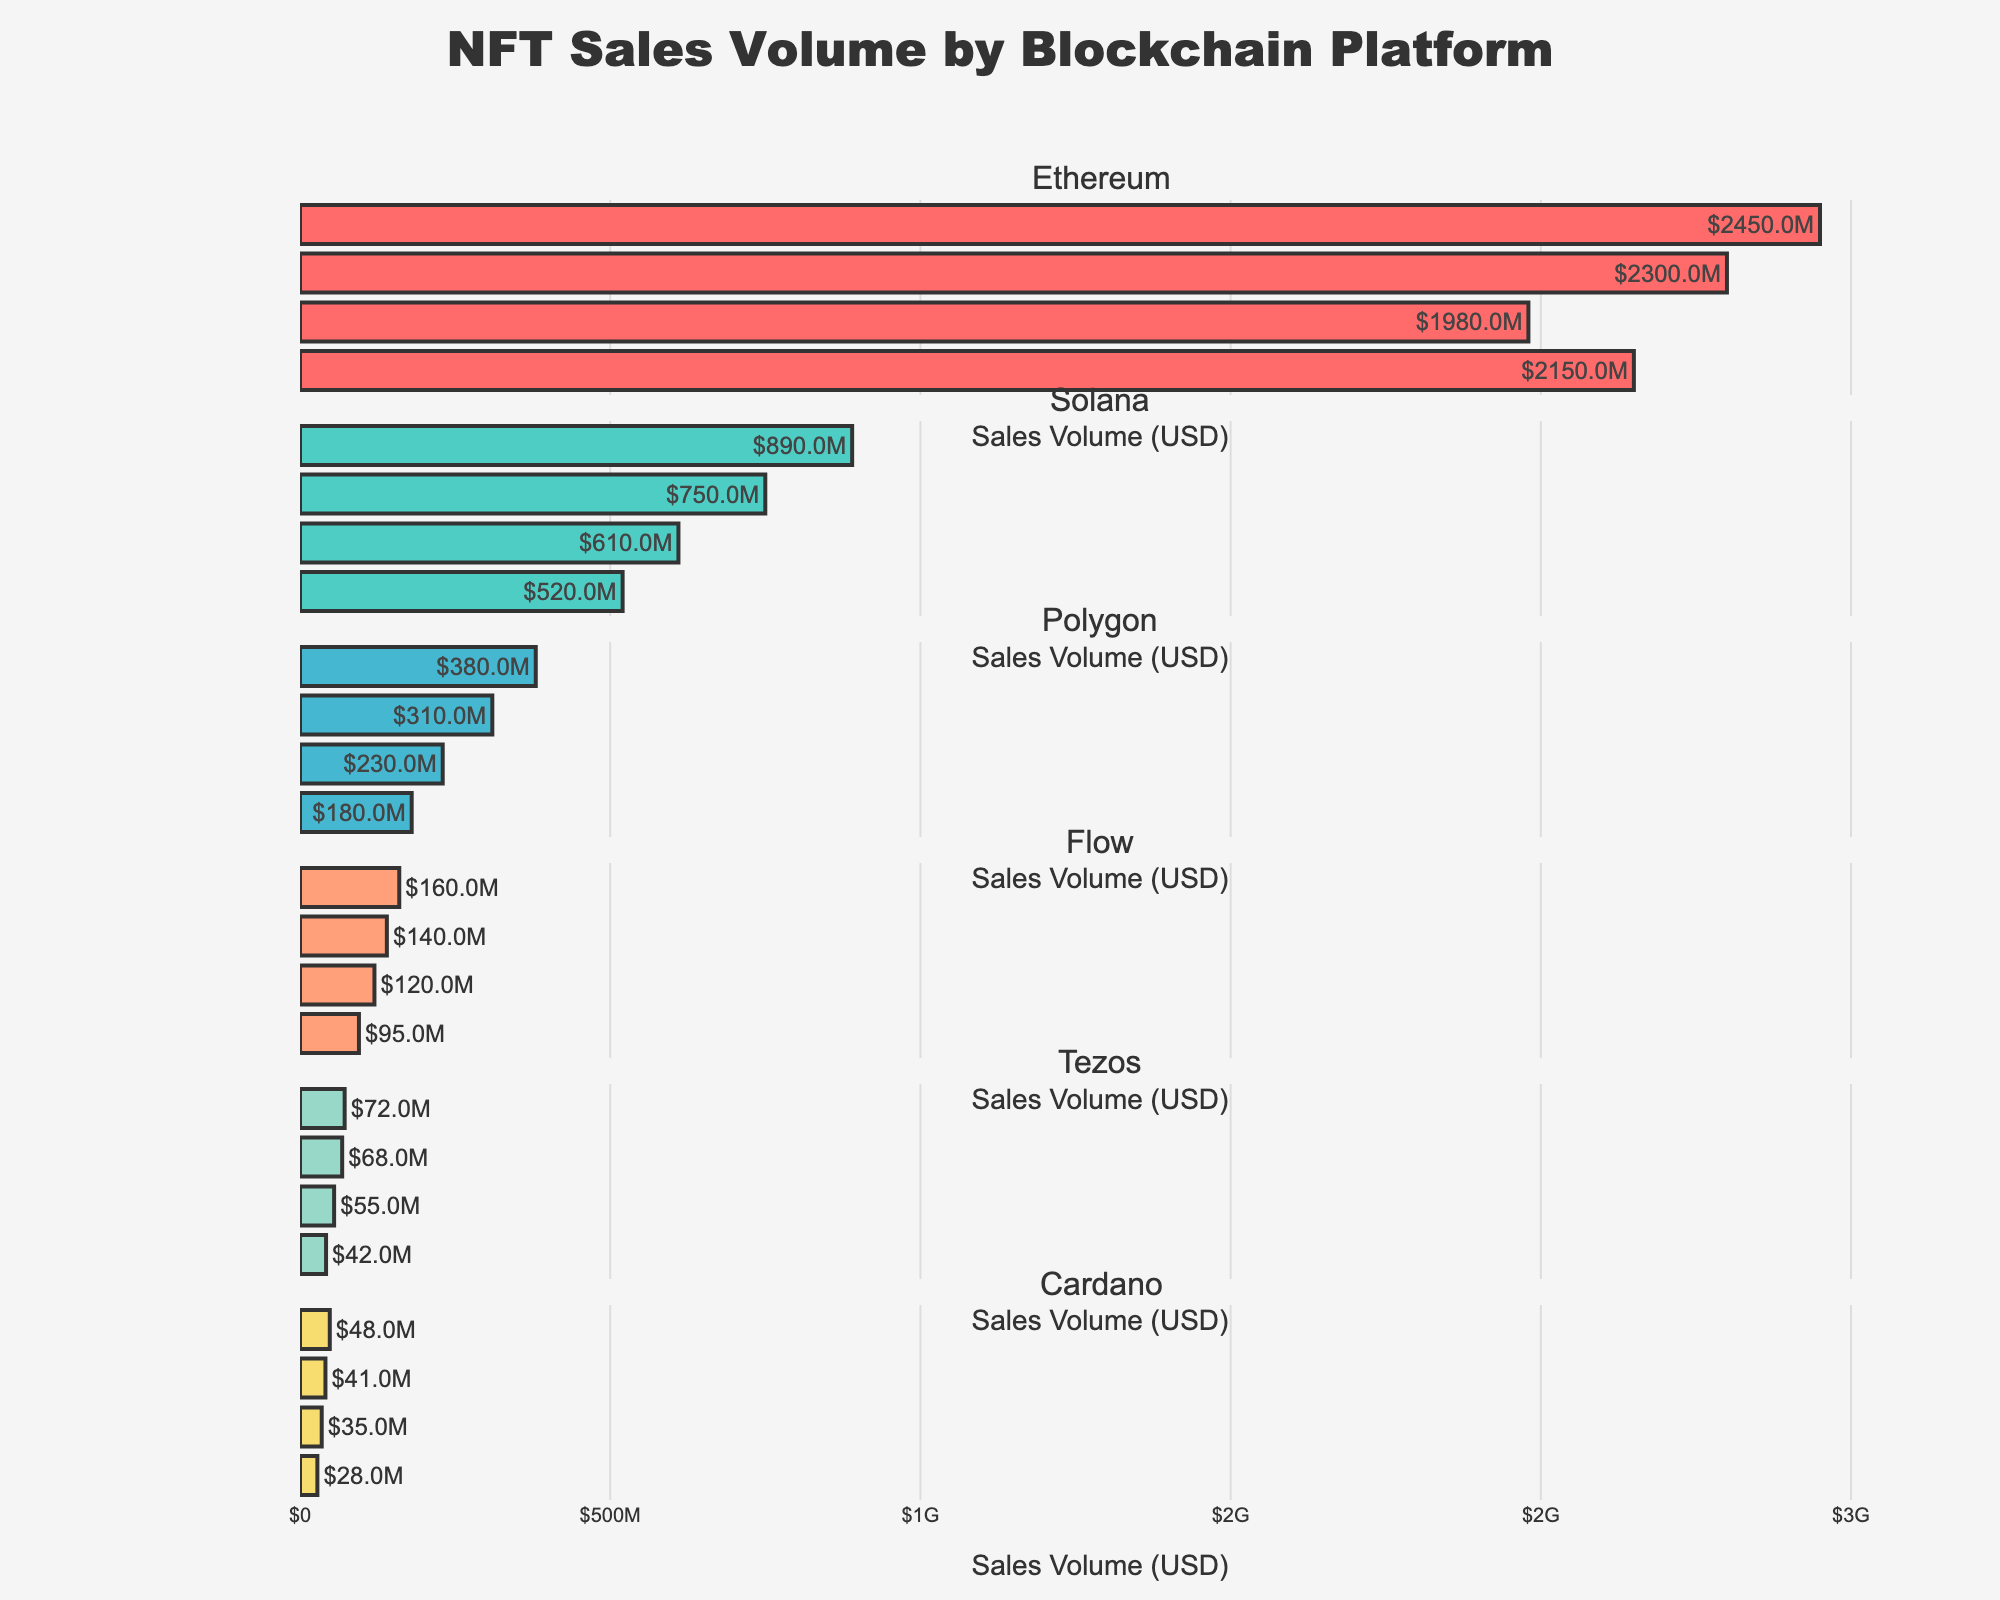What's the title of the figure? The title is located at the top of the figure, often in a larger and bolder font to indicate what the figure is about. The title for this figure is clearly labeled at the top.
Answer: NFT Sales Volume by Blockchain Platform How many blockchain platforms are represented in the figure? The figure has a subplot for each blockchain platform where the sales volume data is displayed. Each subplot is titled with the name of the blockchain platform. By counting these titles, we can determine the number of blockchain platforms.
Answer: 6 Which blockchain had the highest NFT sales volume in Q4 2023? Look at the horizontal bars for Q4 2023 across all the subplots and identify the bar with the greatest length. The corresponding blockchain title will indicate which blockchain had the highest sales volume.
Answer: Ethereum What's the total NFT sales volume of Polygon in Q1 and Q2 2023 combined? Sum the sales volumes of Polygon for Q1 2023 and Q2 2023. The sales volume for Polygon in Q1 2023 is $180M, and in Q2 2023 is $230M. Adding these gives $180M + $230M = $410M.
Answer: $410M Between Solana and Flow in Q2 2023, which blockchain had a higher NFT sales volume, and by how much? Compare the bar lengths (or values) for Solana and Flow in the Q2 2023 subplot. Solana had $610M, and Flow had $120M. Subtract the smaller value from the larger one to find the difference: $610M - $120M = $490M.
Answer: Solana by $490M What's the trend observed for Cardano's NFT sales volume across the four quarters in 2023? Check the lengths of the bars for Cardano in each quarter: Q1 2023, Q2 2023, Q3 2023, and Q4 2023. Observe if they are increasing, decreasing, or remaining constant.
Answer: Increasing What's the average NFT sales volume for Ethereum across the four quarters in 2023? Add the sales volumes for the four quarters and divide by four: (2150M + 1980M + 2300M + 2450M) / 4. The calculation is (8880M) / 4 = 2220M.
Answer: $2220M Which quarter had the highest total sales volume considering all blockchain platforms together? Sum the sales volumes of all blockchain platforms for each quarter and identify the quarter with the highest sum. Calculations: For Q1 2023: 2150M + 520M + 180M + 95M + 42M + 28M = $3015M, for Q2 2023: 1980M + 610M + 230M + 120M + 55M + 35M = $3030M, for Q3 2023: 2300M + 750M + 310M + 140M + 68M + 41M = $3609M, for Q4 2023: 2450M + 890M + 380M + 160M + 72M + 48M = $4000M. Q4 2023 has the highest total with $4000M.
Answer: Q4 2023 